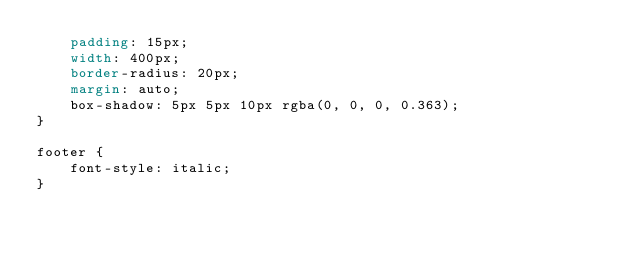<code> <loc_0><loc_0><loc_500><loc_500><_CSS_>    padding: 15px;
    width: 400px;
    border-radius: 20px;
    margin: auto;
    box-shadow: 5px 5px 10px rgba(0, 0, 0, 0.363);
}

footer {
    font-style: italic;
}</code> 